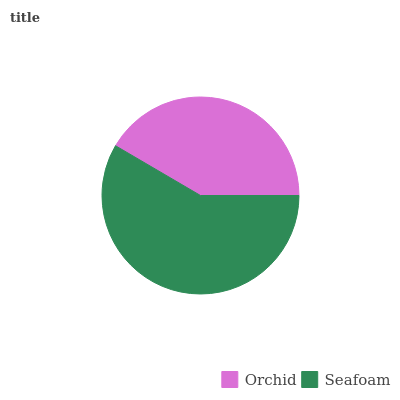Is Orchid the minimum?
Answer yes or no. Yes. Is Seafoam the maximum?
Answer yes or no. Yes. Is Seafoam the minimum?
Answer yes or no. No. Is Seafoam greater than Orchid?
Answer yes or no. Yes. Is Orchid less than Seafoam?
Answer yes or no. Yes. Is Orchid greater than Seafoam?
Answer yes or no. No. Is Seafoam less than Orchid?
Answer yes or no. No. Is Seafoam the high median?
Answer yes or no. Yes. Is Orchid the low median?
Answer yes or no. Yes. Is Orchid the high median?
Answer yes or no. No. Is Seafoam the low median?
Answer yes or no. No. 